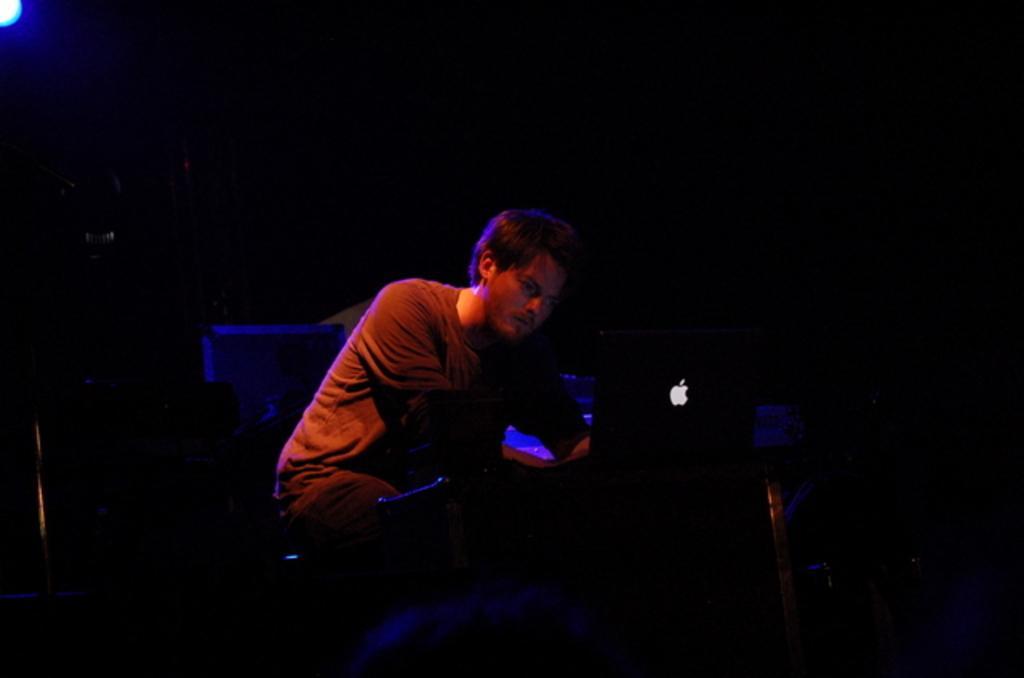Could you give a brief overview of what you see in this image? In the center of the image we can see a man sitting in front of the table and on the table we can see an apple laptop. We can also see another laptop in the background. Image also consists of a light and the background of the image is in black color. 